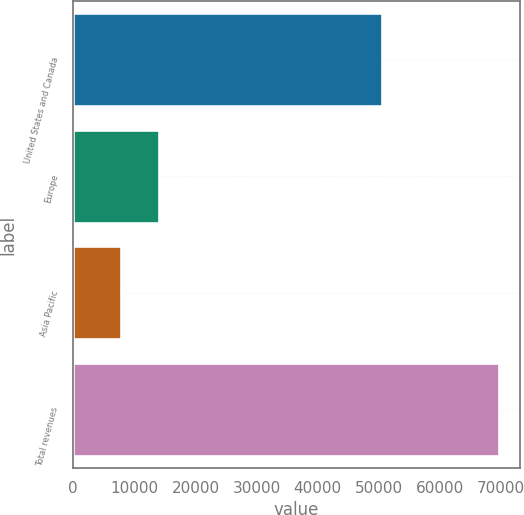Convert chart to OTSL. <chart><loc_0><loc_0><loc_500><loc_500><bar_chart><fcel>United States and Canada<fcel>Europe<fcel>Asia Pacific<fcel>Total revenues<nl><fcel>50555<fcel>13973.4<fcel>7796<fcel>69570<nl></chart> 